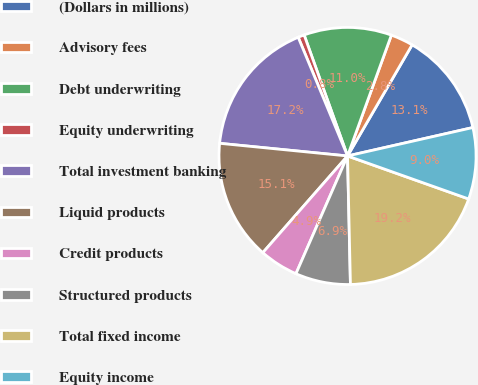Convert chart to OTSL. <chart><loc_0><loc_0><loc_500><loc_500><pie_chart><fcel>(Dollars in millions)<fcel>Advisory fees<fcel>Debt underwriting<fcel>Equity underwriting<fcel>Total investment banking<fcel>Liquid products<fcel>Credit products<fcel>Structured products<fcel>Total fixed income<fcel>Equity income<nl><fcel>13.07%<fcel>2.84%<fcel>11.02%<fcel>0.79%<fcel>17.16%<fcel>15.12%<fcel>4.88%<fcel>6.93%<fcel>19.21%<fcel>8.98%<nl></chart> 